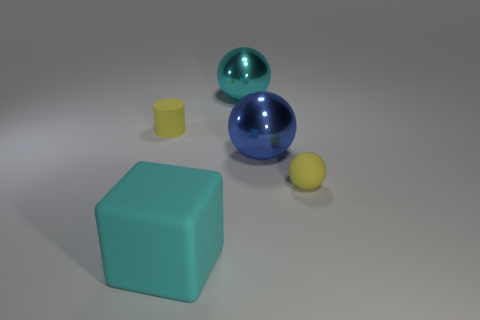Describe the lighting and shadows in the image, and what they reveal about the setting. The soft shadows and diffuse lighting indicate an environment with a broad light source, suggesting indoor, controlled lighting, possibly for product display or photography purposes. The lighting doesn't cast harsh shadows, which underscores the objects' shapes and textures without distracting glare or contrast. 